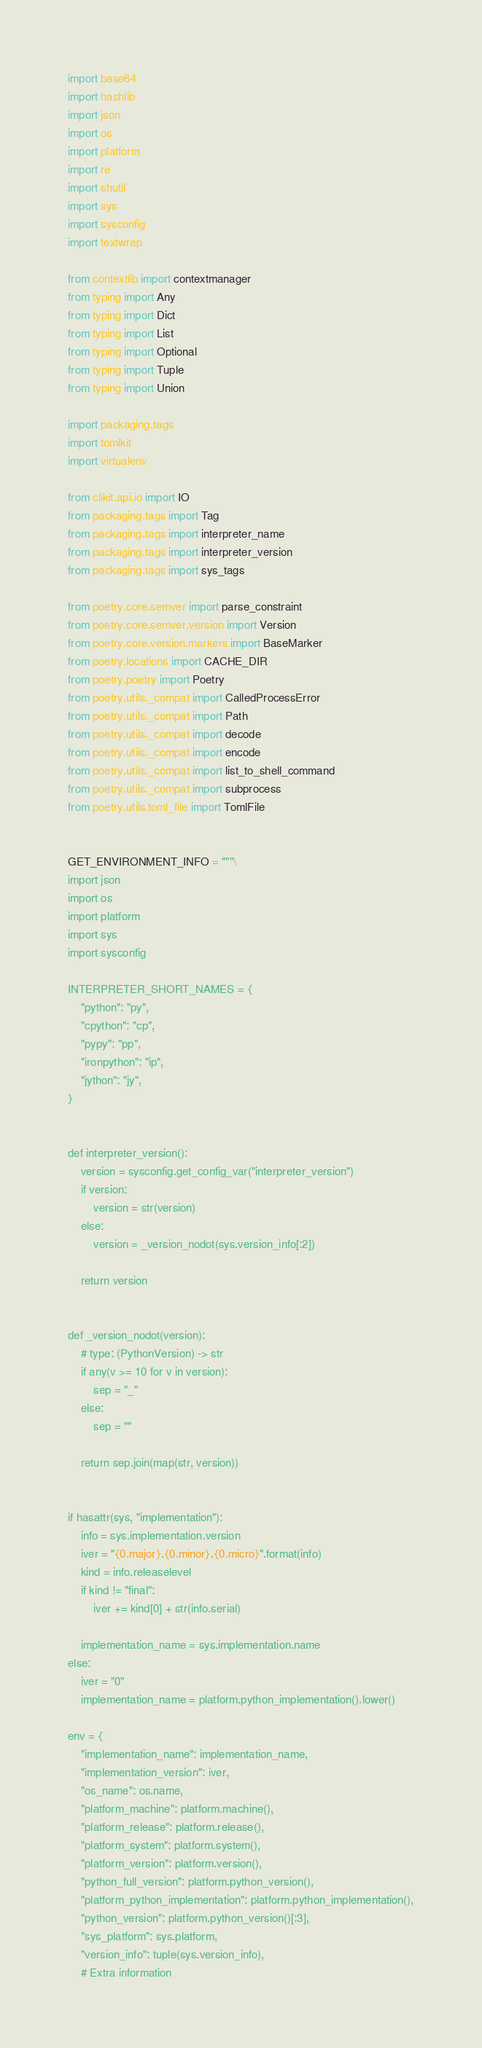<code> <loc_0><loc_0><loc_500><loc_500><_Python_>import base64
import hashlib
import json
import os
import platform
import re
import shutil
import sys
import sysconfig
import textwrap

from contextlib import contextmanager
from typing import Any
from typing import Dict
from typing import List
from typing import Optional
from typing import Tuple
from typing import Union

import packaging.tags
import tomlkit
import virtualenv

from clikit.api.io import IO
from packaging.tags import Tag
from packaging.tags import interpreter_name
from packaging.tags import interpreter_version
from packaging.tags import sys_tags

from poetry.core.semver import parse_constraint
from poetry.core.semver.version import Version
from poetry.core.version.markers import BaseMarker
from poetry.locations import CACHE_DIR
from poetry.poetry import Poetry
from poetry.utils._compat import CalledProcessError
from poetry.utils._compat import Path
from poetry.utils._compat import decode
from poetry.utils._compat import encode
from poetry.utils._compat import list_to_shell_command
from poetry.utils._compat import subprocess
from poetry.utils.toml_file import TomlFile


GET_ENVIRONMENT_INFO = """\
import json
import os
import platform
import sys
import sysconfig

INTERPRETER_SHORT_NAMES = {
    "python": "py",
    "cpython": "cp",
    "pypy": "pp",
    "ironpython": "ip",
    "jython": "jy",
}


def interpreter_version():
    version = sysconfig.get_config_var("interpreter_version")
    if version:
        version = str(version)
    else:
        version = _version_nodot(sys.version_info[:2])

    return version


def _version_nodot(version):
    # type: (PythonVersion) -> str
    if any(v >= 10 for v in version):
        sep = "_"
    else:
        sep = ""

    return sep.join(map(str, version))


if hasattr(sys, "implementation"):
    info = sys.implementation.version
    iver = "{0.major}.{0.minor}.{0.micro}".format(info)
    kind = info.releaselevel
    if kind != "final":
        iver += kind[0] + str(info.serial)

    implementation_name = sys.implementation.name
else:
    iver = "0"
    implementation_name = platform.python_implementation().lower()

env = {
    "implementation_name": implementation_name,
    "implementation_version": iver,
    "os_name": os.name,
    "platform_machine": platform.machine(),
    "platform_release": platform.release(),
    "platform_system": platform.system(),
    "platform_version": platform.version(),
    "python_full_version": platform.python_version(),
    "platform_python_implementation": platform.python_implementation(),
    "python_version": platform.python_version()[:3],
    "sys_platform": sys.platform,
    "version_info": tuple(sys.version_info),
    # Extra information</code> 